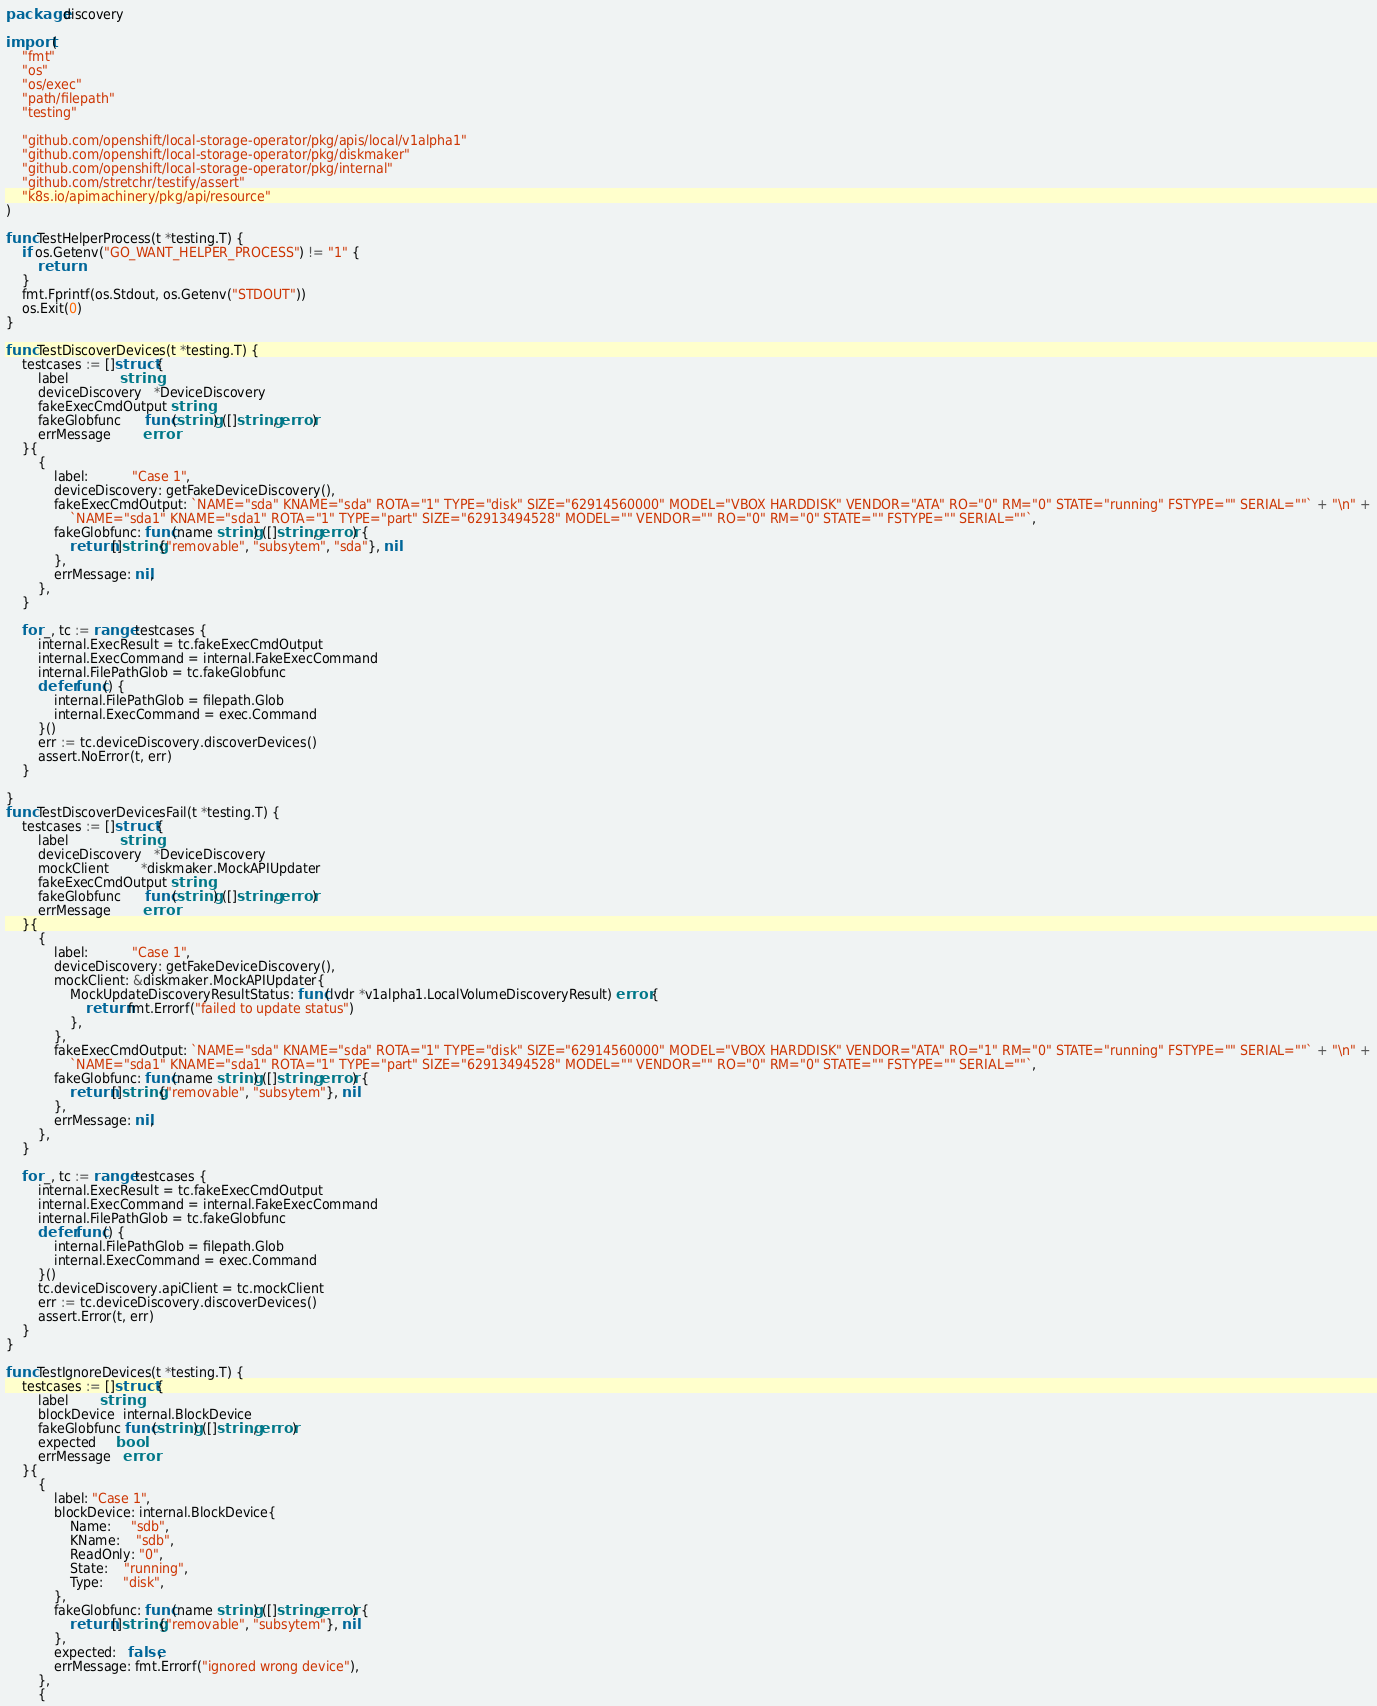Convert code to text. <code><loc_0><loc_0><loc_500><loc_500><_Go_>package discovery

import (
	"fmt"
	"os"
	"os/exec"
	"path/filepath"
	"testing"

	"github.com/openshift/local-storage-operator/pkg/apis/local/v1alpha1"
	"github.com/openshift/local-storage-operator/pkg/diskmaker"
	"github.com/openshift/local-storage-operator/pkg/internal"
	"github.com/stretchr/testify/assert"
	"k8s.io/apimachinery/pkg/api/resource"
)

func TestHelperProcess(t *testing.T) {
	if os.Getenv("GO_WANT_HELPER_PROCESS") != "1" {
		return
	}
	fmt.Fprintf(os.Stdout, os.Getenv("STDOUT"))
	os.Exit(0)
}

func TestDiscoverDevices(t *testing.T) {
	testcases := []struct {
		label             string
		deviceDiscovery   *DeviceDiscovery
		fakeExecCmdOutput string
		fakeGlobfunc      func(string) ([]string, error)
		errMessage        error
	}{
		{
			label:           "Case 1",
			deviceDiscovery: getFakeDeviceDiscovery(),
			fakeExecCmdOutput: `NAME="sda" KNAME="sda" ROTA="1" TYPE="disk" SIZE="62914560000" MODEL="VBOX HARDDISK" VENDOR="ATA" RO="0" RM="0" STATE="running" FSTYPE="" SERIAL=""` + "\n" +
				`NAME="sda1" KNAME="sda1" ROTA="1" TYPE="part" SIZE="62913494528" MODEL="" VENDOR="" RO="0" RM="0" STATE="" FSTYPE="" SERIAL=""`,
			fakeGlobfunc: func(name string) ([]string, error) {
				return []string{"removable", "subsytem", "sda"}, nil
			},
			errMessage: nil,
		},
	}

	for _, tc := range testcases {
		internal.ExecResult = tc.fakeExecCmdOutput
		internal.ExecCommand = internal.FakeExecCommand
		internal.FilePathGlob = tc.fakeGlobfunc
		defer func() {
			internal.FilePathGlob = filepath.Glob
			internal.ExecCommand = exec.Command
		}()
		err := tc.deviceDiscovery.discoverDevices()
		assert.NoError(t, err)
	}

}
func TestDiscoverDevicesFail(t *testing.T) {
	testcases := []struct {
		label             string
		deviceDiscovery   *DeviceDiscovery
		mockClient        *diskmaker.MockAPIUpdater
		fakeExecCmdOutput string
		fakeGlobfunc      func(string) ([]string, error)
		errMessage        error
	}{
		{
			label:           "Case 1",
			deviceDiscovery: getFakeDeviceDiscovery(),
			mockClient: &diskmaker.MockAPIUpdater{
				MockUpdateDiscoveryResultStatus: func(lvdr *v1alpha1.LocalVolumeDiscoveryResult) error {
					return fmt.Errorf("failed to update status")
				},
			},
			fakeExecCmdOutput: `NAME="sda" KNAME="sda" ROTA="1" TYPE="disk" SIZE="62914560000" MODEL="VBOX HARDDISK" VENDOR="ATA" RO="1" RM="0" STATE="running" FSTYPE="" SERIAL=""` + "\n" +
				`NAME="sda1" KNAME="sda1" ROTA="1" TYPE="part" SIZE="62913494528" MODEL="" VENDOR="" RO="0" RM="0" STATE="" FSTYPE="" SERIAL=""`,
			fakeGlobfunc: func(name string) ([]string, error) {
				return []string{"removable", "subsytem"}, nil
			},
			errMessage: nil,
		},
	}

	for _, tc := range testcases {
		internal.ExecResult = tc.fakeExecCmdOutput
		internal.ExecCommand = internal.FakeExecCommand
		internal.FilePathGlob = tc.fakeGlobfunc
		defer func() {
			internal.FilePathGlob = filepath.Glob
			internal.ExecCommand = exec.Command
		}()
		tc.deviceDiscovery.apiClient = tc.mockClient
		err := tc.deviceDiscovery.discoverDevices()
		assert.Error(t, err)
	}
}

func TestIgnoreDevices(t *testing.T) {
	testcases := []struct {
		label        string
		blockDevice  internal.BlockDevice
		fakeGlobfunc func(string) ([]string, error)
		expected     bool
		errMessage   error
	}{
		{
			label: "Case 1",
			blockDevice: internal.BlockDevice{
				Name:     "sdb",
				KName:    "sdb",
				ReadOnly: "0",
				State:    "running",
				Type:     "disk",
			},
			fakeGlobfunc: func(name string) ([]string, error) {
				return []string{"removable", "subsytem"}, nil
			},
			expected:   false,
			errMessage: fmt.Errorf("ignored wrong device"),
		},
		{</code> 